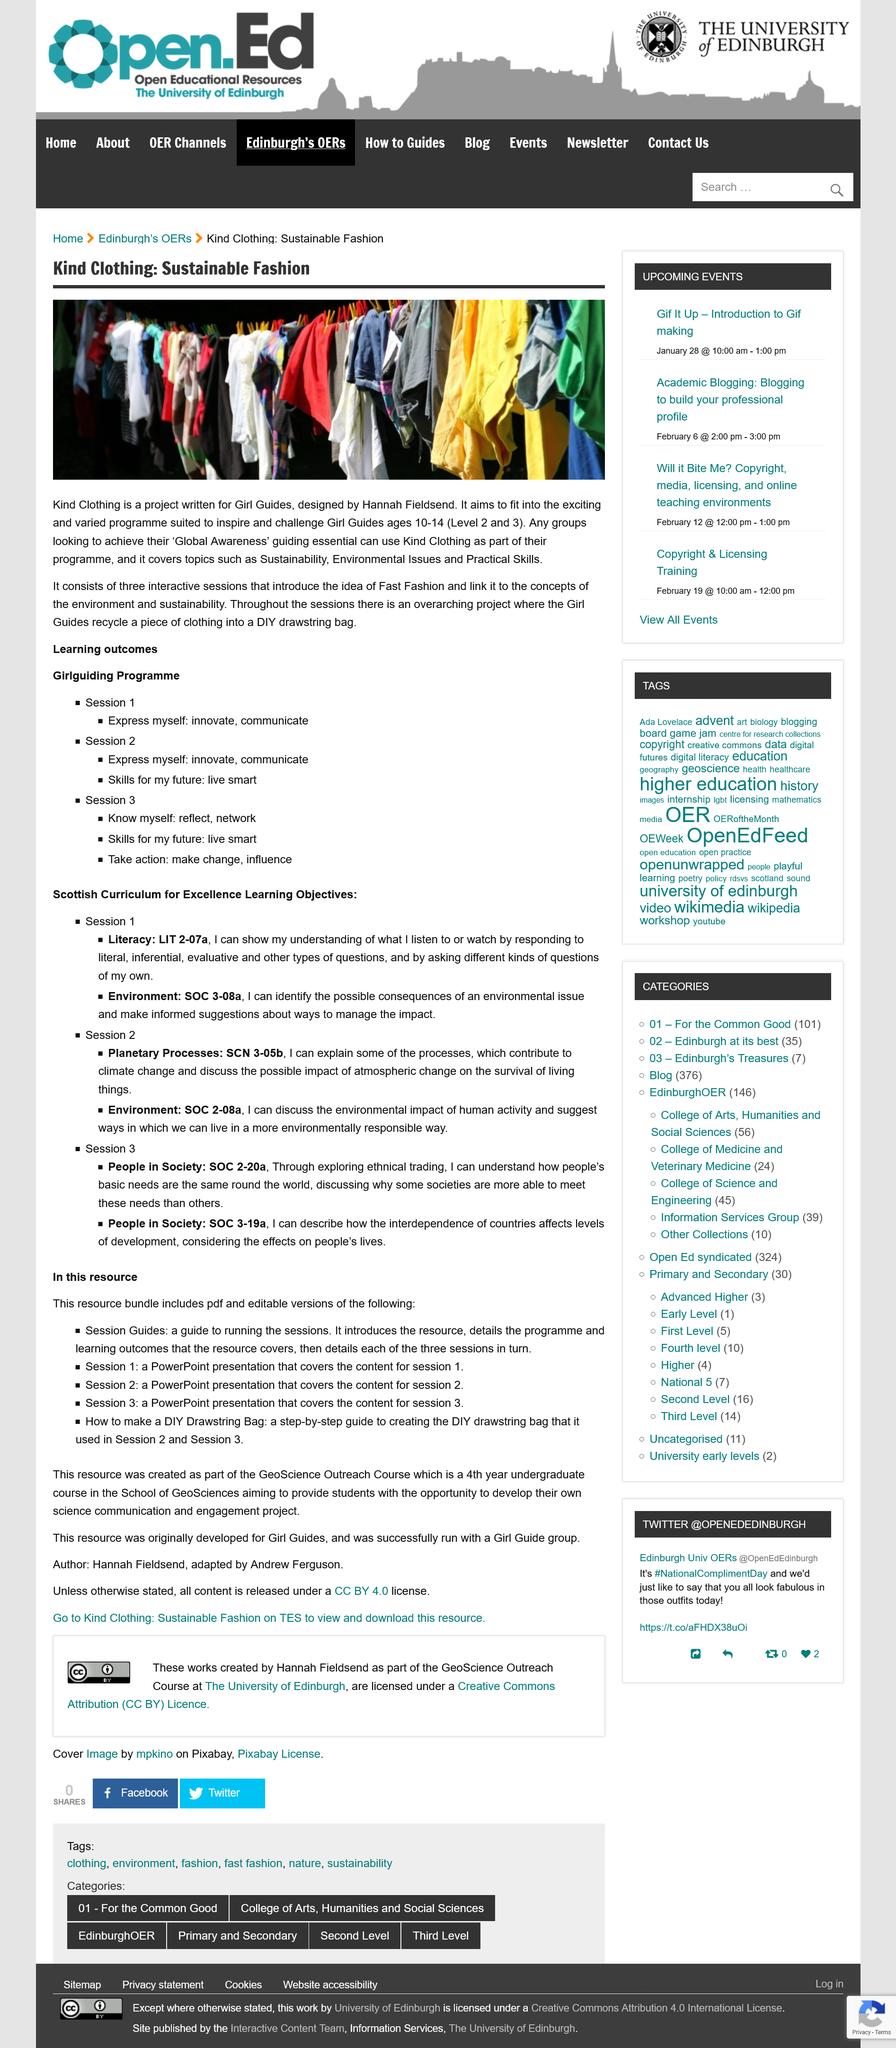List a handful of essential elements in this visual. Hannah Fieldsend designed The Kind Clothing project. The Girguiding program includes three sessions. In the Kind Clothing project, Girl Guides recycle a piece of clothing into a DIY drawstring bag. 